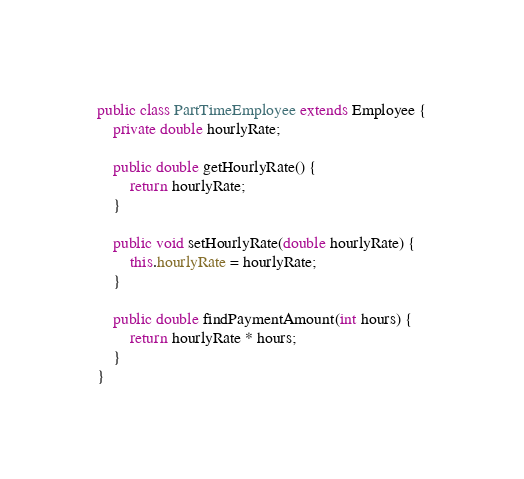Convert code to text. <code><loc_0><loc_0><loc_500><loc_500><_Java_>
public class PartTimeEmployee extends Employee {
	private double hourlyRate;

	public double getHourlyRate() {
		return hourlyRate;
	}

	public void setHourlyRate(double hourlyRate) {
		this.hourlyRate = hourlyRate;
	}
	
	public double findPaymentAmount(int hours) {
		return hourlyRate * hours;
	}
}
</code> 